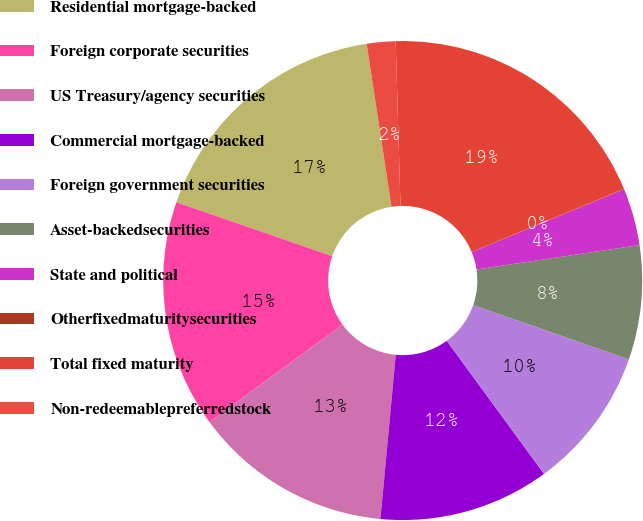Convert chart to OTSL. <chart><loc_0><loc_0><loc_500><loc_500><pie_chart><fcel>Residential mortgage-backed<fcel>Foreign corporate securities<fcel>US Treasury/agency securities<fcel>Commercial mortgage-backed<fcel>Foreign government securities<fcel>Asset-backedsecurities<fcel>State and political<fcel>Otherfixedmaturitysecurities<fcel>Total fixed maturity<fcel>Non-redeemablepreferredstock<nl><fcel>17.29%<fcel>15.37%<fcel>13.45%<fcel>11.53%<fcel>9.62%<fcel>7.7%<fcel>3.86%<fcel>0.03%<fcel>19.21%<fcel>1.94%<nl></chart> 